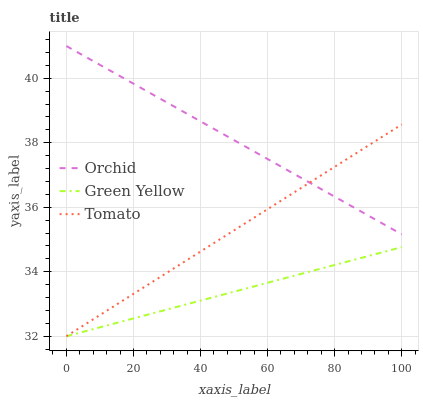Does Orchid have the minimum area under the curve?
Answer yes or no. No. Does Green Yellow have the maximum area under the curve?
Answer yes or no. No. Is Orchid the smoothest?
Answer yes or no. No. Is Green Yellow the roughest?
Answer yes or no. No. Does Orchid have the lowest value?
Answer yes or no. No. Does Green Yellow have the highest value?
Answer yes or no. No. Is Green Yellow less than Orchid?
Answer yes or no. Yes. Is Orchid greater than Green Yellow?
Answer yes or no. Yes. Does Green Yellow intersect Orchid?
Answer yes or no. No. 